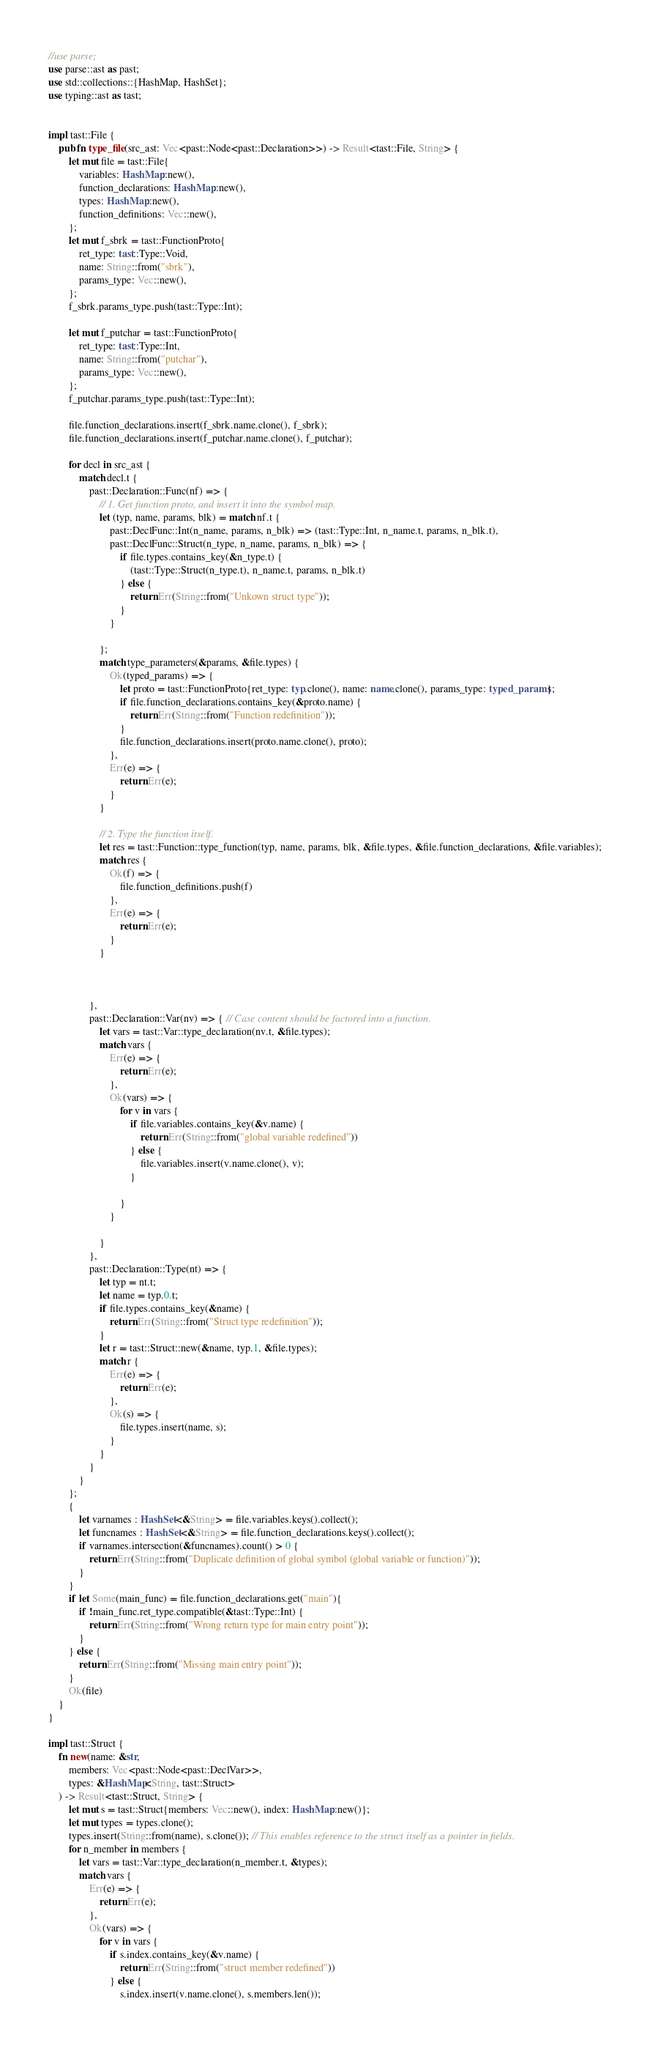Convert code to text. <code><loc_0><loc_0><loc_500><loc_500><_Rust_>//use parse;
use parse::ast as past;
use std::collections::{HashMap, HashSet};
use typing::ast as tast;


impl tast::File {
    pub fn type_file(src_ast: Vec<past::Node<past::Declaration>>) -> Result<tast::File, String> {
        let mut file = tast::File{
            variables: HashMap::new(),
            function_declarations: HashMap::new(),
            types: HashMap::new(),
            function_definitions: Vec::new(),
        };
        let mut f_sbrk = tast::FunctionProto{
            ret_type: tast::Type::Void,
            name: String::from("sbrk"),
            params_type: Vec::new(),
        };
        f_sbrk.params_type.push(tast::Type::Int);

        let mut f_putchar = tast::FunctionProto{
            ret_type: tast::Type::Int,
            name: String::from("putchar"),
            params_type: Vec::new(),
        };
        f_putchar.params_type.push(tast::Type::Int);

        file.function_declarations.insert(f_sbrk.name.clone(), f_sbrk);
        file.function_declarations.insert(f_putchar.name.clone(), f_putchar);

        for decl in src_ast {
            match decl.t {
                past::Declaration::Func(nf) => {
                    // 1. Get function proto, and insert it into the symbol map.
                    let (typ, name, params, blk) = match nf.t {
                        past::DeclFunc::Int(n_name, params, n_blk) => (tast::Type::Int, n_name.t, params, n_blk.t),
                        past::DeclFunc::Struct(n_type, n_name, params, n_blk) => {
                            if file.types.contains_key(&n_type.t) {
                                (tast::Type::Struct(n_type.t), n_name.t, params, n_blk.t)
                            } else {
                                return Err(String::from("Unkown struct type"));
                            }
                        }

                    };
                    match type_parameters(&params, &file.types) {
                        Ok(typed_params) => {
                            let proto = tast::FunctionProto{ret_type: typ.clone(), name: name.clone(), params_type: typed_params};
                            if file.function_declarations.contains_key(&proto.name) {
                                return Err(String::from("Function redefinition"));
                            }
                            file.function_declarations.insert(proto.name.clone(), proto);
                        },
                        Err(e) => {
                            return Err(e);
                        }
                    }

                    // 2. Type the function itself.
                    let res = tast::Function::type_function(typ, name, params, blk, &file.types, &file.function_declarations, &file.variables);
                    match res {
                        Ok(f) => {
                            file.function_definitions.push(f)
                        },
                        Err(e) => {
                            return Err(e);
                        }
                    }



                },
                past::Declaration::Var(nv) => { // Case content should be factored into a function.
                    let vars = tast::Var::type_declaration(nv.t, &file.types);
                    match vars {
                        Err(e) => {
                            return Err(e);
                        },
                        Ok(vars) => {
                            for v in vars {
                                if file.variables.contains_key(&v.name) {
                                    return Err(String::from("global variable redefined"))
                                } else {
                                    file.variables.insert(v.name.clone(), v);
                                }

                            }
                        }

                    }
                },
                past::Declaration::Type(nt) => {
                    let typ = nt.t;
                    let name = typ.0.t;
                    if file.types.contains_key(&name) {
                        return Err(String::from("Struct type redefinition"));
                    }
                    let r = tast::Struct::new(&name, typ.1, &file.types);
                    match r {
                        Err(e) => {
                            return Err(e);
                        },
                        Ok(s) => {
                            file.types.insert(name, s);
                        }
                    }
                }
            }
        };
        {
            let varnames : HashSet<&String> = file.variables.keys().collect();
            let funcnames : HashSet<&String> = file.function_declarations.keys().collect();
            if varnames.intersection(&funcnames).count() > 0 {
                return Err(String::from("Duplicate definition of global symbol (global variable or function)"));
            }
        }
        if let Some(main_func) = file.function_declarations.get("main"){
            if !main_func.ret_type.compatible(&tast::Type::Int) {
                return Err(String::from("Wrong return type for main entry point"));
            }
        } else {
            return Err(String::from("Missing main entry point"));
        }
        Ok(file)
    }
}

impl tast::Struct {
    fn new(name: &str,
        members: Vec<past::Node<past::DeclVar>>,
        types: &HashMap<String, tast::Struct>
    ) -> Result<tast::Struct, String> {
        let mut s = tast::Struct{members: Vec::new(), index: HashMap::new()};
        let mut types = types.clone();
        types.insert(String::from(name), s.clone()); // This enables reference to the struct itself as a pointer in fields.
        for n_member in members {
            let vars = tast::Var::type_declaration(n_member.t, &types);
            match vars {
                Err(e) => {
                    return Err(e);
                },
                Ok(vars) => {
                    for v in vars {
                        if s.index.contains_key(&v.name) {
                            return Err(String::from("struct member redefined"))
                        } else {
                            s.index.insert(v.name.clone(), s.members.len());</code> 